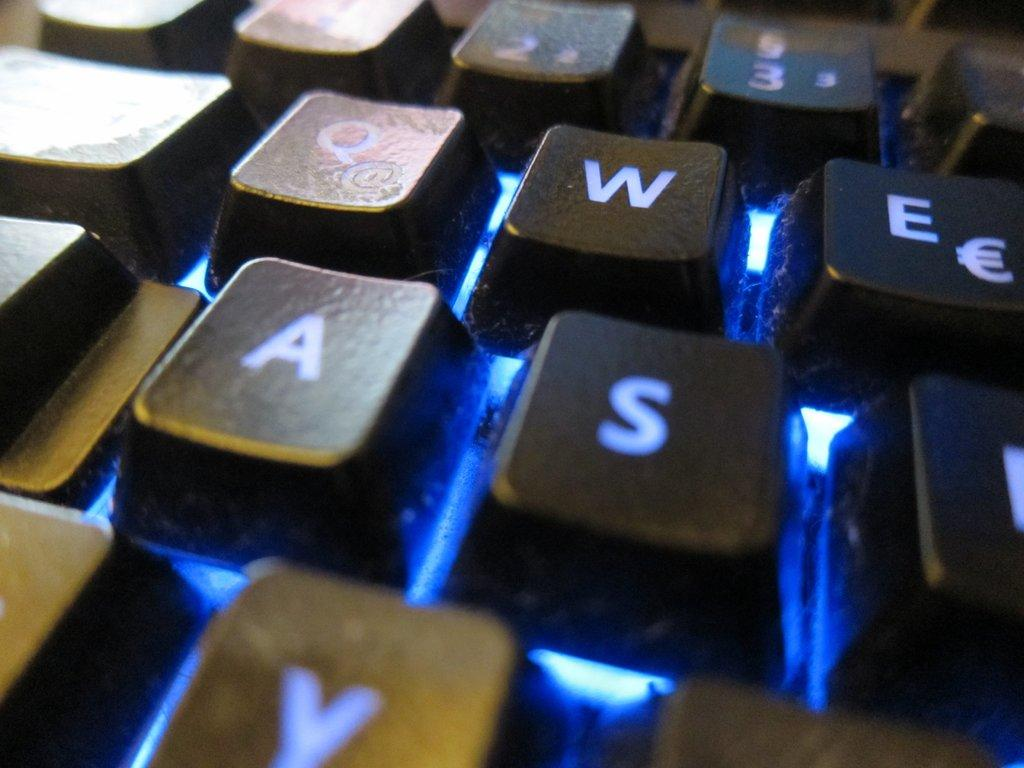<image>
Present a compact description of the photo's key features. A keyboard displaying the Q, W, A, and S keys prominently with blue lighting. 